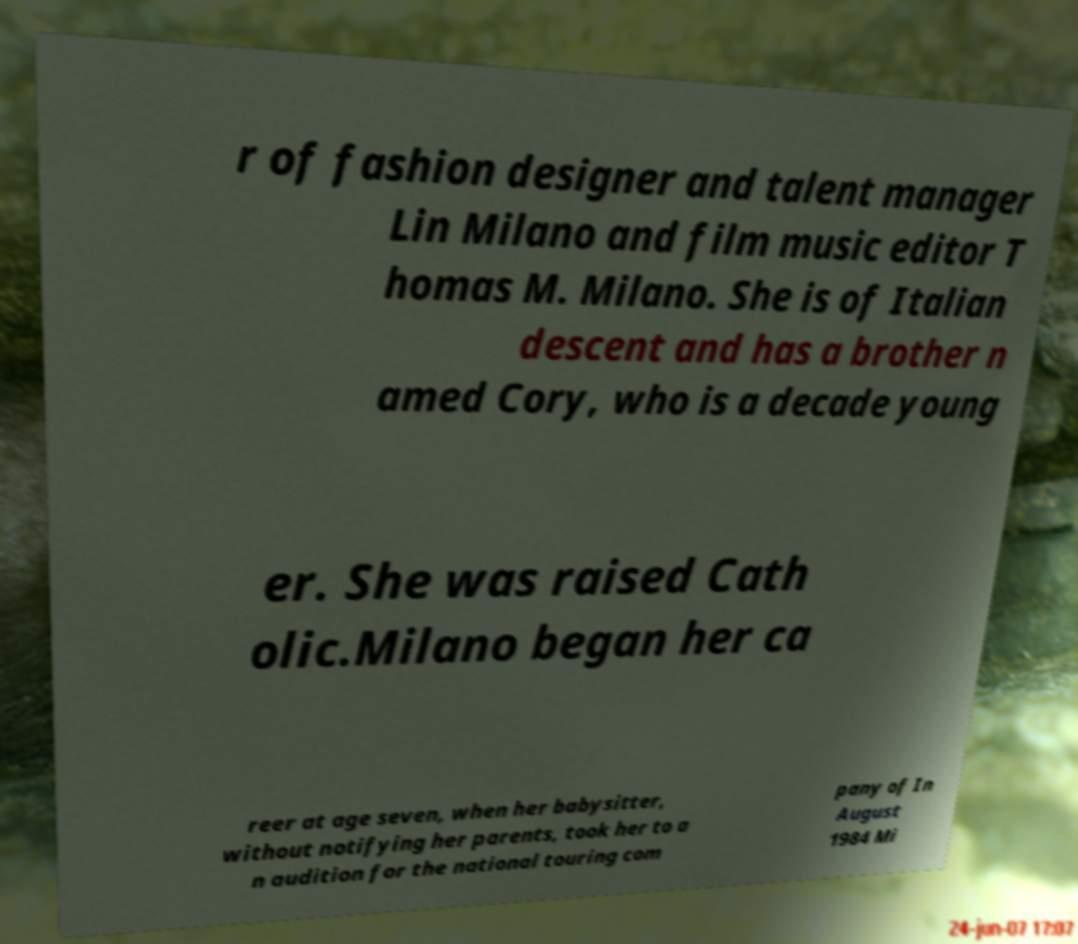There's text embedded in this image that I need extracted. Can you transcribe it verbatim? r of fashion designer and talent manager Lin Milano and film music editor T homas M. Milano. She is of Italian descent and has a brother n amed Cory, who is a decade young er. She was raised Cath olic.Milano began her ca reer at age seven, when her babysitter, without notifying her parents, took her to a n audition for the national touring com pany of In August 1984 Mi 